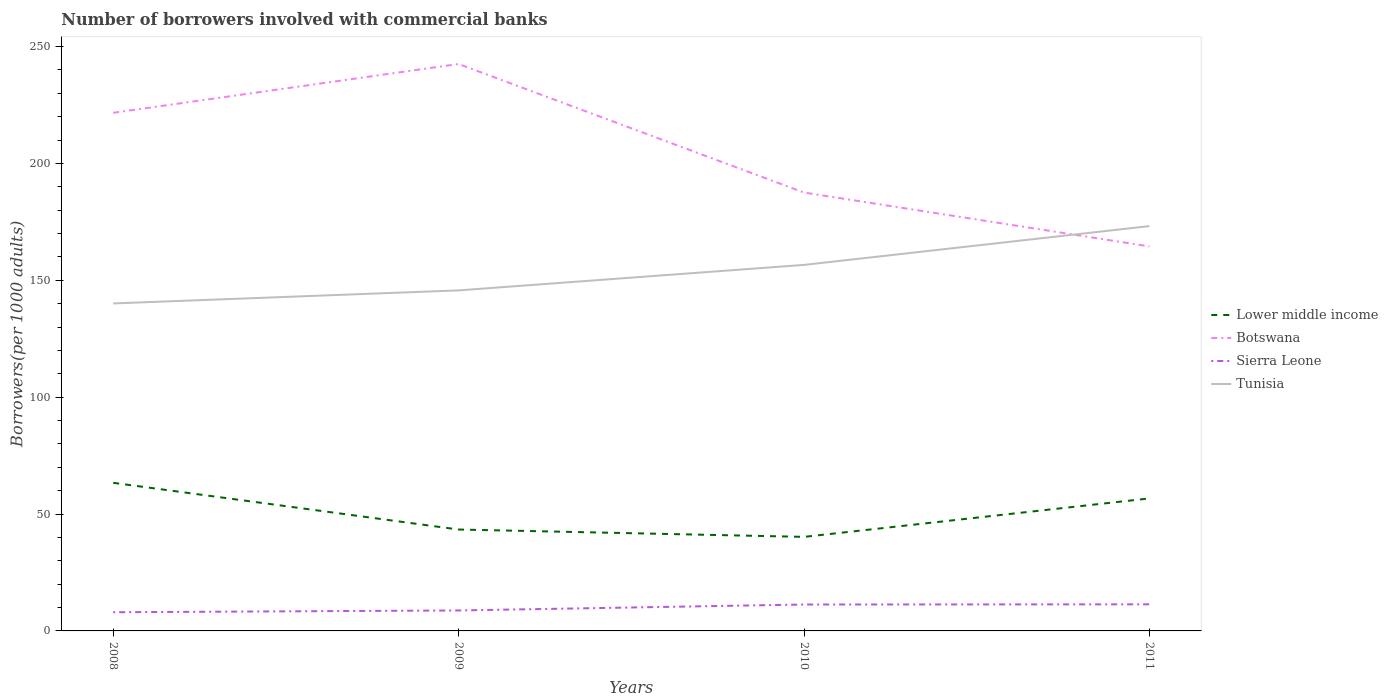Does the line corresponding to Botswana intersect with the line corresponding to Tunisia?
Give a very brief answer. Yes. Is the number of lines equal to the number of legend labels?
Give a very brief answer. Yes. Across all years, what is the maximum number of borrowers involved with commercial banks in Lower middle income?
Offer a very short reply. 40.23. What is the total number of borrowers involved with commercial banks in Lower middle income in the graph?
Your response must be concise. 19.98. What is the difference between the highest and the second highest number of borrowers involved with commercial banks in Tunisia?
Give a very brief answer. 33.08. Does the graph contain any zero values?
Offer a terse response. No. Does the graph contain grids?
Your answer should be very brief. No. How are the legend labels stacked?
Keep it short and to the point. Vertical. What is the title of the graph?
Your response must be concise. Number of borrowers involved with commercial banks. Does "Kenya" appear as one of the legend labels in the graph?
Provide a short and direct response. No. What is the label or title of the X-axis?
Your response must be concise. Years. What is the label or title of the Y-axis?
Your answer should be compact. Borrowers(per 1000 adults). What is the Borrowers(per 1000 adults) in Lower middle income in 2008?
Your response must be concise. 63.36. What is the Borrowers(per 1000 adults) of Botswana in 2008?
Make the answer very short. 221.65. What is the Borrowers(per 1000 adults) in Sierra Leone in 2008?
Your answer should be compact. 7.99. What is the Borrowers(per 1000 adults) of Tunisia in 2008?
Your answer should be compact. 140.09. What is the Borrowers(per 1000 adults) in Lower middle income in 2009?
Ensure brevity in your answer.  43.38. What is the Borrowers(per 1000 adults) in Botswana in 2009?
Provide a succinct answer. 242.52. What is the Borrowers(per 1000 adults) in Sierra Leone in 2009?
Provide a succinct answer. 8.75. What is the Borrowers(per 1000 adults) of Tunisia in 2009?
Offer a very short reply. 145.68. What is the Borrowers(per 1000 adults) in Lower middle income in 2010?
Your response must be concise. 40.23. What is the Borrowers(per 1000 adults) of Botswana in 2010?
Give a very brief answer. 187.53. What is the Borrowers(per 1000 adults) of Sierra Leone in 2010?
Offer a very short reply. 11.3. What is the Borrowers(per 1000 adults) of Tunisia in 2010?
Ensure brevity in your answer.  156.58. What is the Borrowers(per 1000 adults) of Lower middle income in 2011?
Your answer should be compact. 56.68. What is the Borrowers(per 1000 adults) of Botswana in 2011?
Your answer should be compact. 164.48. What is the Borrowers(per 1000 adults) in Sierra Leone in 2011?
Provide a short and direct response. 11.37. What is the Borrowers(per 1000 adults) of Tunisia in 2011?
Make the answer very short. 173.17. Across all years, what is the maximum Borrowers(per 1000 adults) of Lower middle income?
Make the answer very short. 63.36. Across all years, what is the maximum Borrowers(per 1000 adults) in Botswana?
Provide a succinct answer. 242.52. Across all years, what is the maximum Borrowers(per 1000 adults) of Sierra Leone?
Ensure brevity in your answer.  11.37. Across all years, what is the maximum Borrowers(per 1000 adults) of Tunisia?
Keep it short and to the point. 173.17. Across all years, what is the minimum Borrowers(per 1000 adults) of Lower middle income?
Ensure brevity in your answer.  40.23. Across all years, what is the minimum Borrowers(per 1000 adults) in Botswana?
Your response must be concise. 164.48. Across all years, what is the minimum Borrowers(per 1000 adults) of Sierra Leone?
Keep it short and to the point. 7.99. Across all years, what is the minimum Borrowers(per 1000 adults) of Tunisia?
Your answer should be very brief. 140.09. What is the total Borrowers(per 1000 adults) in Lower middle income in the graph?
Ensure brevity in your answer.  203.65. What is the total Borrowers(per 1000 adults) of Botswana in the graph?
Your answer should be very brief. 816.18. What is the total Borrowers(per 1000 adults) of Sierra Leone in the graph?
Provide a succinct answer. 39.42. What is the total Borrowers(per 1000 adults) of Tunisia in the graph?
Your answer should be very brief. 615.51. What is the difference between the Borrowers(per 1000 adults) in Lower middle income in 2008 and that in 2009?
Make the answer very short. 19.98. What is the difference between the Borrowers(per 1000 adults) in Botswana in 2008 and that in 2009?
Make the answer very short. -20.87. What is the difference between the Borrowers(per 1000 adults) in Sierra Leone in 2008 and that in 2009?
Your answer should be compact. -0.76. What is the difference between the Borrowers(per 1000 adults) of Tunisia in 2008 and that in 2009?
Give a very brief answer. -5.59. What is the difference between the Borrowers(per 1000 adults) in Lower middle income in 2008 and that in 2010?
Your response must be concise. 23.13. What is the difference between the Borrowers(per 1000 adults) in Botswana in 2008 and that in 2010?
Make the answer very short. 34.12. What is the difference between the Borrowers(per 1000 adults) in Sierra Leone in 2008 and that in 2010?
Your answer should be compact. -3.3. What is the difference between the Borrowers(per 1000 adults) of Tunisia in 2008 and that in 2010?
Offer a terse response. -16.49. What is the difference between the Borrowers(per 1000 adults) of Lower middle income in 2008 and that in 2011?
Your response must be concise. 6.67. What is the difference between the Borrowers(per 1000 adults) in Botswana in 2008 and that in 2011?
Your response must be concise. 57.17. What is the difference between the Borrowers(per 1000 adults) in Sierra Leone in 2008 and that in 2011?
Offer a very short reply. -3.38. What is the difference between the Borrowers(per 1000 adults) of Tunisia in 2008 and that in 2011?
Give a very brief answer. -33.08. What is the difference between the Borrowers(per 1000 adults) of Lower middle income in 2009 and that in 2010?
Give a very brief answer. 3.15. What is the difference between the Borrowers(per 1000 adults) in Botswana in 2009 and that in 2010?
Give a very brief answer. 55. What is the difference between the Borrowers(per 1000 adults) in Sierra Leone in 2009 and that in 2010?
Your answer should be compact. -2.54. What is the difference between the Borrowers(per 1000 adults) of Tunisia in 2009 and that in 2010?
Your answer should be very brief. -10.9. What is the difference between the Borrowers(per 1000 adults) of Lower middle income in 2009 and that in 2011?
Provide a short and direct response. -13.31. What is the difference between the Borrowers(per 1000 adults) in Botswana in 2009 and that in 2011?
Keep it short and to the point. 78.04. What is the difference between the Borrowers(per 1000 adults) in Sierra Leone in 2009 and that in 2011?
Your answer should be compact. -2.62. What is the difference between the Borrowers(per 1000 adults) in Tunisia in 2009 and that in 2011?
Make the answer very short. -27.5. What is the difference between the Borrowers(per 1000 adults) of Lower middle income in 2010 and that in 2011?
Your answer should be compact. -16.45. What is the difference between the Borrowers(per 1000 adults) of Botswana in 2010 and that in 2011?
Offer a terse response. 23.05. What is the difference between the Borrowers(per 1000 adults) of Sierra Leone in 2010 and that in 2011?
Keep it short and to the point. -0.08. What is the difference between the Borrowers(per 1000 adults) of Tunisia in 2010 and that in 2011?
Make the answer very short. -16.59. What is the difference between the Borrowers(per 1000 adults) of Lower middle income in 2008 and the Borrowers(per 1000 adults) of Botswana in 2009?
Your answer should be compact. -179.16. What is the difference between the Borrowers(per 1000 adults) of Lower middle income in 2008 and the Borrowers(per 1000 adults) of Sierra Leone in 2009?
Your response must be concise. 54.6. What is the difference between the Borrowers(per 1000 adults) of Lower middle income in 2008 and the Borrowers(per 1000 adults) of Tunisia in 2009?
Your answer should be very brief. -82.32. What is the difference between the Borrowers(per 1000 adults) in Botswana in 2008 and the Borrowers(per 1000 adults) in Sierra Leone in 2009?
Provide a succinct answer. 212.9. What is the difference between the Borrowers(per 1000 adults) in Botswana in 2008 and the Borrowers(per 1000 adults) in Tunisia in 2009?
Give a very brief answer. 75.97. What is the difference between the Borrowers(per 1000 adults) of Sierra Leone in 2008 and the Borrowers(per 1000 adults) of Tunisia in 2009?
Your answer should be very brief. -137.68. What is the difference between the Borrowers(per 1000 adults) of Lower middle income in 2008 and the Borrowers(per 1000 adults) of Botswana in 2010?
Your answer should be compact. -124.17. What is the difference between the Borrowers(per 1000 adults) in Lower middle income in 2008 and the Borrowers(per 1000 adults) in Sierra Leone in 2010?
Ensure brevity in your answer.  52.06. What is the difference between the Borrowers(per 1000 adults) in Lower middle income in 2008 and the Borrowers(per 1000 adults) in Tunisia in 2010?
Offer a terse response. -93.22. What is the difference between the Borrowers(per 1000 adults) of Botswana in 2008 and the Borrowers(per 1000 adults) of Sierra Leone in 2010?
Keep it short and to the point. 210.35. What is the difference between the Borrowers(per 1000 adults) in Botswana in 2008 and the Borrowers(per 1000 adults) in Tunisia in 2010?
Provide a short and direct response. 65.07. What is the difference between the Borrowers(per 1000 adults) in Sierra Leone in 2008 and the Borrowers(per 1000 adults) in Tunisia in 2010?
Ensure brevity in your answer.  -148.59. What is the difference between the Borrowers(per 1000 adults) in Lower middle income in 2008 and the Borrowers(per 1000 adults) in Botswana in 2011?
Offer a terse response. -101.12. What is the difference between the Borrowers(per 1000 adults) in Lower middle income in 2008 and the Borrowers(per 1000 adults) in Sierra Leone in 2011?
Your answer should be compact. 51.98. What is the difference between the Borrowers(per 1000 adults) in Lower middle income in 2008 and the Borrowers(per 1000 adults) in Tunisia in 2011?
Provide a short and direct response. -109.81. What is the difference between the Borrowers(per 1000 adults) of Botswana in 2008 and the Borrowers(per 1000 adults) of Sierra Leone in 2011?
Offer a very short reply. 210.28. What is the difference between the Borrowers(per 1000 adults) of Botswana in 2008 and the Borrowers(per 1000 adults) of Tunisia in 2011?
Provide a succinct answer. 48.48. What is the difference between the Borrowers(per 1000 adults) in Sierra Leone in 2008 and the Borrowers(per 1000 adults) in Tunisia in 2011?
Make the answer very short. -165.18. What is the difference between the Borrowers(per 1000 adults) in Lower middle income in 2009 and the Borrowers(per 1000 adults) in Botswana in 2010?
Offer a terse response. -144.15. What is the difference between the Borrowers(per 1000 adults) of Lower middle income in 2009 and the Borrowers(per 1000 adults) of Sierra Leone in 2010?
Provide a succinct answer. 32.08. What is the difference between the Borrowers(per 1000 adults) in Lower middle income in 2009 and the Borrowers(per 1000 adults) in Tunisia in 2010?
Keep it short and to the point. -113.2. What is the difference between the Borrowers(per 1000 adults) in Botswana in 2009 and the Borrowers(per 1000 adults) in Sierra Leone in 2010?
Keep it short and to the point. 231.22. What is the difference between the Borrowers(per 1000 adults) of Botswana in 2009 and the Borrowers(per 1000 adults) of Tunisia in 2010?
Your response must be concise. 85.94. What is the difference between the Borrowers(per 1000 adults) of Sierra Leone in 2009 and the Borrowers(per 1000 adults) of Tunisia in 2010?
Provide a short and direct response. -147.83. What is the difference between the Borrowers(per 1000 adults) of Lower middle income in 2009 and the Borrowers(per 1000 adults) of Botswana in 2011?
Offer a terse response. -121.1. What is the difference between the Borrowers(per 1000 adults) of Lower middle income in 2009 and the Borrowers(per 1000 adults) of Sierra Leone in 2011?
Offer a terse response. 32. What is the difference between the Borrowers(per 1000 adults) in Lower middle income in 2009 and the Borrowers(per 1000 adults) in Tunisia in 2011?
Make the answer very short. -129.79. What is the difference between the Borrowers(per 1000 adults) of Botswana in 2009 and the Borrowers(per 1000 adults) of Sierra Leone in 2011?
Give a very brief answer. 231.15. What is the difference between the Borrowers(per 1000 adults) of Botswana in 2009 and the Borrowers(per 1000 adults) of Tunisia in 2011?
Give a very brief answer. 69.35. What is the difference between the Borrowers(per 1000 adults) of Sierra Leone in 2009 and the Borrowers(per 1000 adults) of Tunisia in 2011?
Keep it short and to the point. -164.42. What is the difference between the Borrowers(per 1000 adults) of Lower middle income in 2010 and the Borrowers(per 1000 adults) of Botswana in 2011?
Provide a succinct answer. -124.25. What is the difference between the Borrowers(per 1000 adults) in Lower middle income in 2010 and the Borrowers(per 1000 adults) in Sierra Leone in 2011?
Provide a short and direct response. 28.86. What is the difference between the Borrowers(per 1000 adults) in Lower middle income in 2010 and the Borrowers(per 1000 adults) in Tunisia in 2011?
Provide a succinct answer. -132.94. What is the difference between the Borrowers(per 1000 adults) in Botswana in 2010 and the Borrowers(per 1000 adults) in Sierra Leone in 2011?
Your answer should be compact. 176.15. What is the difference between the Borrowers(per 1000 adults) in Botswana in 2010 and the Borrowers(per 1000 adults) in Tunisia in 2011?
Provide a short and direct response. 14.36. What is the difference between the Borrowers(per 1000 adults) in Sierra Leone in 2010 and the Borrowers(per 1000 adults) in Tunisia in 2011?
Keep it short and to the point. -161.87. What is the average Borrowers(per 1000 adults) of Lower middle income per year?
Offer a very short reply. 50.91. What is the average Borrowers(per 1000 adults) of Botswana per year?
Your response must be concise. 204.04. What is the average Borrowers(per 1000 adults) in Sierra Leone per year?
Offer a very short reply. 9.86. What is the average Borrowers(per 1000 adults) of Tunisia per year?
Keep it short and to the point. 153.88. In the year 2008, what is the difference between the Borrowers(per 1000 adults) in Lower middle income and Borrowers(per 1000 adults) in Botswana?
Your response must be concise. -158.29. In the year 2008, what is the difference between the Borrowers(per 1000 adults) of Lower middle income and Borrowers(per 1000 adults) of Sierra Leone?
Your answer should be compact. 55.36. In the year 2008, what is the difference between the Borrowers(per 1000 adults) in Lower middle income and Borrowers(per 1000 adults) in Tunisia?
Your answer should be very brief. -76.73. In the year 2008, what is the difference between the Borrowers(per 1000 adults) in Botswana and Borrowers(per 1000 adults) in Sierra Leone?
Keep it short and to the point. 213.66. In the year 2008, what is the difference between the Borrowers(per 1000 adults) in Botswana and Borrowers(per 1000 adults) in Tunisia?
Provide a succinct answer. 81.56. In the year 2008, what is the difference between the Borrowers(per 1000 adults) of Sierra Leone and Borrowers(per 1000 adults) of Tunisia?
Provide a short and direct response. -132.09. In the year 2009, what is the difference between the Borrowers(per 1000 adults) in Lower middle income and Borrowers(per 1000 adults) in Botswana?
Provide a succinct answer. -199.15. In the year 2009, what is the difference between the Borrowers(per 1000 adults) of Lower middle income and Borrowers(per 1000 adults) of Sierra Leone?
Your response must be concise. 34.62. In the year 2009, what is the difference between the Borrowers(per 1000 adults) in Lower middle income and Borrowers(per 1000 adults) in Tunisia?
Make the answer very short. -102.3. In the year 2009, what is the difference between the Borrowers(per 1000 adults) in Botswana and Borrowers(per 1000 adults) in Sierra Leone?
Provide a short and direct response. 233.77. In the year 2009, what is the difference between the Borrowers(per 1000 adults) of Botswana and Borrowers(per 1000 adults) of Tunisia?
Make the answer very short. 96.85. In the year 2009, what is the difference between the Borrowers(per 1000 adults) in Sierra Leone and Borrowers(per 1000 adults) in Tunisia?
Provide a succinct answer. -136.92. In the year 2010, what is the difference between the Borrowers(per 1000 adults) in Lower middle income and Borrowers(per 1000 adults) in Botswana?
Give a very brief answer. -147.3. In the year 2010, what is the difference between the Borrowers(per 1000 adults) in Lower middle income and Borrowers(per 1000 adults) in Sierra Leone?
Provide a succinct answer. 28.93. In the year 2010, what is the difference between the Borrowers(per 1000 adults) in Lower middle income and Borrowers(per 1000 adults) in Tunisia?
Your response must be concise. -116.35. In the year 2010, what is the difference between the Borrowers(per 1000 adults) of Botswana and Borrowers(per 1000 adults) of Sierra Leone?
Your response must be concise. 176.23. In the year 2010, what is the difference between the Borrowers(per 1000 adults) of Botswana and Borrowers(per 1000 adults) of Tunisia?
Offer a terse response. 30.95. In the year 2010, what is the difference between the Borrowers(per 1000 adults) of Sierra Leone and Borrowers(per 1000 adults) of Tunisia?
Ensure brevity in your answer.  -145.28. In the year 2011, what is the difference between the Borrowers(per 1000 adults) in Lower middle income and Borrowers(per 1000 adults) in Botswana?
Your answer should be very brief. -107.79. In the year 2011, what is the difference between the Borrowers(per 1000 adults) in Lower middle income and Borrowers(per 1000 adults) in Sierra Leone?
Your response must be concise. 45.31. In the year 2011, what is the difference between the Borrowers(per 1000 adults) of Lower middle income and Borrowers(per 1000 adults) of Tunisia?
Offer a terse response. -116.49. In the year 2011, what is the difference between the Borrowers(per 1000 adults) of Botswana and Borrowers(per 1000 adults) of Sierra Leone?
Give a very brief answer. 153.1. In the year 2011, what is the difference between the Borrowers(per 1000 adults) of Botswana and Borrowers(per 1000 adults) of Tunisia?
Provide a succinct answer. -8.69. In the year 2011, what is the difference between the Borrowers(per 1000 adults) in Sierra Leone and Borrowers(per 1000 adults) in Tunisia?
Your response must be concise. -161.8. What is the ratio of the Borrowers(per 1000 adults) in Lower middle income in 2008 to that in 2009?
Offer a terse response. 1.46. What is the ratio of the Borrowers(per 1000 adults) of Botswana in 2008 to that in 2009?
Keep it short and to the point. 0.91. What is the ratio of the Borrowers(per 1000 adults) in Sierra Leone in 2008 to that in 2009?
Provide a short and direct response. 0.91. What is the ratio of the Borrowers(per 1000 adults) of Tunisia in 2008 to that in 2009?
Your answer should be very brief. 0.96. What is the ratio of the Borrowers(per 1000 adults) of Lower middle income in 2008 to that in 2010?
Make the answer very short. 1.57. What is the ratio of the Borrowers(per 1000 adults) in Botswana in 2008 to that in 2010?
Keep it short and to the point. 1.18. What is the ratio of the Borrowers(per 1000 adults) of Sierra Leone in 2008 to that in 2010?
Make the answer very short. 0.71. What is the ratio of the Borrowers(per 1000 adults) in Tunisia in 2008 to that in 2010?
Make the answer very short. 0.89. What is the ratio of the Borrowers(per 1000 adults) of Lower middle income in 2008 to that in 2011?
Offer a terse response. 1.12. What is the ratio of the Borrowers(per 1000 adults) of Botswana in 2008 to that in 2011?
Give a very brief answer. 1.35. What is the ratio of the Borrowers(per 1000 adults) in Sierra Leone in 2008 to that in 2011?
Keep it short and to the point. 0.7. What is the ratio of the Borrowers(per 1000 adults) in Tunisia in 2008 to that in 2011?
Offer a very short reply. 0.81. What is the ratio of the Borrowers(per 1000 adults) in Lower middle income in 2009 to that in 2010?
Keep it short and to the point. 1.08. What is the ratio of the Borrowers(per 1000 adults) of Botswana in 2009 to that in 2010?
Provide a short and direct response. 1.29. What is the ratio of the Borrowers(per 1000 adults) in Sierra Leone in 2009 to that in 2010?
Your answer should be compact. 0.77. What is the ratio of the Borrowers(per 1000 adults) in Tunisia in 2009 to that in 2010?
Give a very brief answer. 0.93. What is the ratio of the Borrowers(per 1000 adults) in Lower middle income in 2009 to that in 2011?
Give a very brief answer. 0.77. What is the ratio of the Borrowers(per 1000 adults) of Botswana in 2009 to that in 2011?
Your answer should be compact. 1.47. What is the ratio of the Borrowers(per 1000 adults) of Sierra Leone in 2009 to that in 2011?
Give a very brief answer. 0.77. What is the ratio of the Borrowers(per 1000 adults) in Tunisia in 2009 to that in 2011?
Make the answer very short. 0.84. What is the ratio of the Borrowers(per 1000 adults) of Lower middle income in 2010 to that in 2011?
Your answer should be very brief. 0.71. What is the ratio of the Borrowers(per 1000 adults) in Botswana in 2010 to that in 2011?
Keep it short and to the point. 1.14. What is the ratio of the Borrowers(per 1000 adults) in Sierra Leone in 2010 to that in 2011?
Provide a short and direct response. 0.99. What is the ratio of the Borrowers(per 1000 adults) of Tunisia in 2010 to that in 2011?
Keep it short and to the point. 0.9. What is the difference between the highest and the second highest Borrowers(per 1000 adults) in Lower middle income?
Offer a very short reply. 6.67. What is the difference between the highest and the second highest Borrowers(per 1000 adults) of Botswana?
Offer a terse response. 20.87. What is the difference between the highest and the second highest Borrowers(per 1000 adults) of Sierra Leone?
Give a very brief answer. 0.08. What is the difference between the highest and the second highest Borrowers(per 1000 adults) of Tunisia?
Your answer should be very brief. 16.59. What is the difference between the highest and the lowest Borrowers(per 1000 adults) in Lower middle income?
Offer a terse response. 23.13. What is the difference between the highest and the lowest Borrowers(per 1000 adults) in Botswana?
Your answer should be compact. 78.04. What is the difference between the highest and the lowest Borrowers(per 1000 adults) of Sierra Leone?
Give a very brief answer. 3.38. What is the difference between the highest and the lowest Borrowers(per 1000 adults) in Tunisia?
Ensure brevity in your answer.  33.08. 